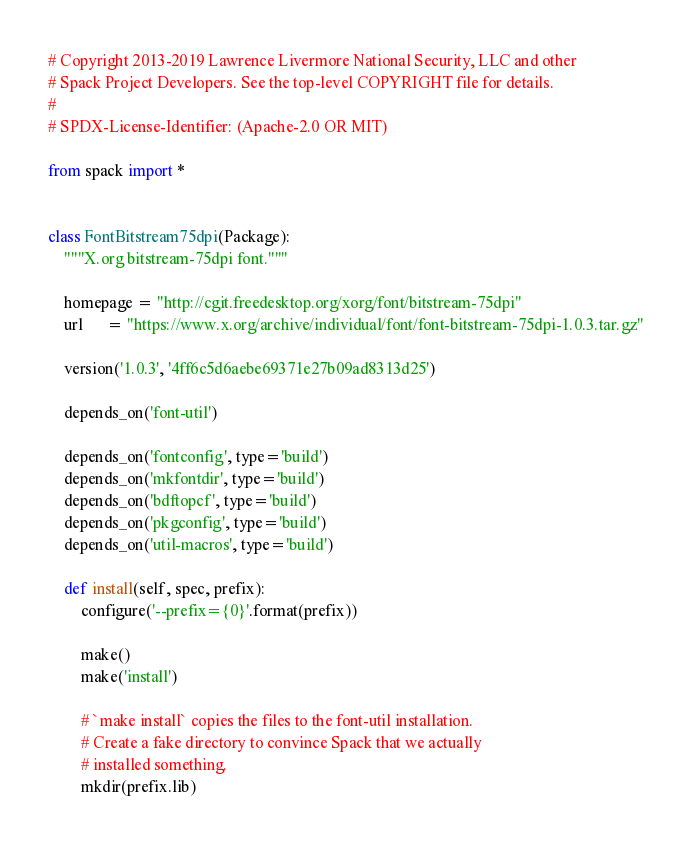<code> <loc_0><loc_0><loc_500><loc_500><_Python_># Copyright 2013-2019 Lawrence Livermore National Security, LLC and other
# Spack Project Developers. See the top-level COPYRIGHT file for details.
#
# SPDX-License-Identifier: (Apache-2.0 OR MIT)

from spack import *


class FontBitstream75dpi(Package):
    """X.org bitstream-75dpi font."""

    homepage = "http://cgit.freedesktop.org/xorg/font/bitstream-75dpi"
    url      = "https://www.x.org/archive/individual/font/font-bitstream-75dpi-1.0.3.tar.gz"

    version('1.0.3', '4ff6c5d6aebe69371e27b09ad8313d25')

    depends_on('font-util')

    depends_on('fontconfig', type='build')
    depends_on('mkfontdir', type='build')
    depends_on('bdftopcf', type='build')
    depends_on('pkgconfig', type='build')
    depends_on('util-macros', type='build')

    def install(self, spec, prefix):
        configure('--prefix={0}'.format(prefix))

        make()
        make('install')

        # `make install` copies the files to the font-util installation.
        # Create a fake directory to convince Spack that we actually
        # installed something.
        mkdir(prefix.lib)
</code> 